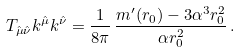<formula> <loc_0><loc_0><loc_500><loc_500>T _ { \hat { \mu } \hat { \nu } } k ^ { \hat { \mu } } k ^ { \hat { \nu } } = \frac { 1 } { 8 \pi } \, \frac { m ^ { \prime } ( r _ { 0 } ) - 3 \alpha ^ { 3 } r _ { 0 } ^ { 2 } } { \alpha r _ { 0 } ^ { 2 } } \, .</formula> 